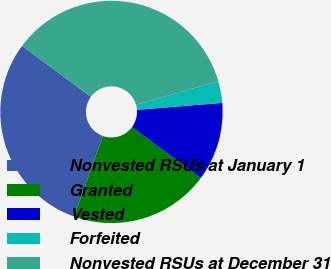Convert chart to OTSL. <chart><loc_0><loc_0><loc_500><loc_500><pie_chart><fcel>Nonvested RSUs at January 1<fcel>Granted<fcel>Vested<fcel>Forfeited<fcel>Nonvested RSUs at December 31<nl><fcel>29.66%<fcel>20.34%<fcel>11.42%<fcel>3.17%<fcel>35.41%<nl></chart> 